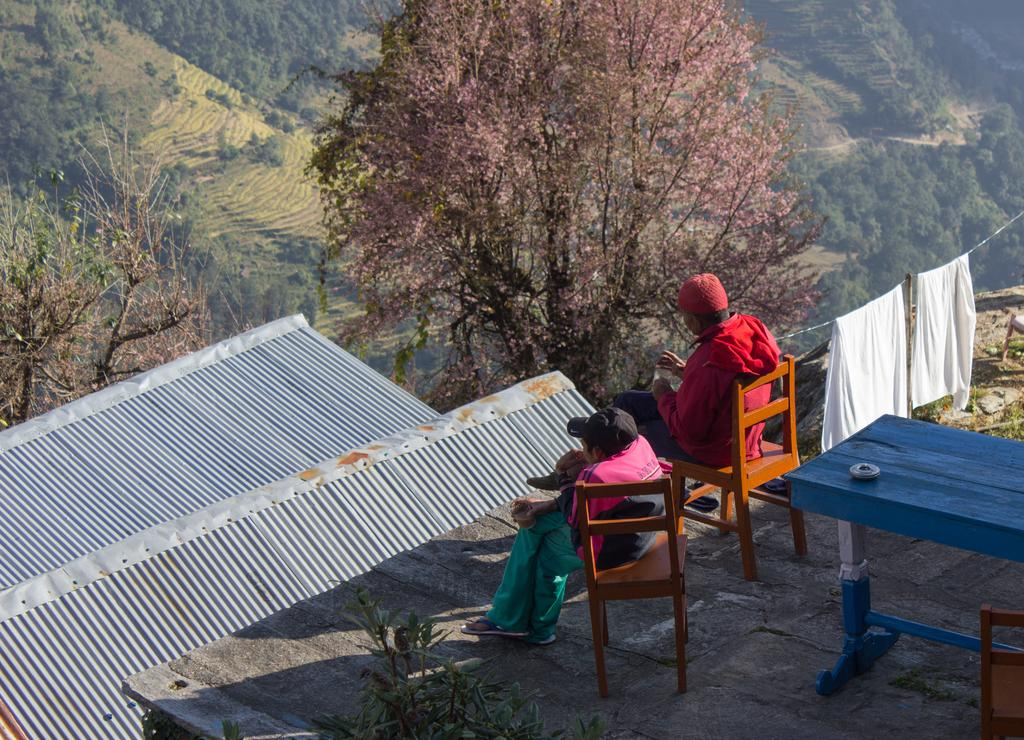Who is present in the image? There is a man and a woman in the image. Where are they sitting? They are sitting on a roof. What is behind them? There is a table behind them. What is the setting of the image? The image is set in a forest area. What can be observed in the surrounding area? There are many trees in the area surrounding the image. What type of fork can be seen in the image? There is no fork present in the image. Can you tell me when the couple in the image was born? The image does not provide information about the birth of the couple; it only shows them sitting on a roof in a forest area. 